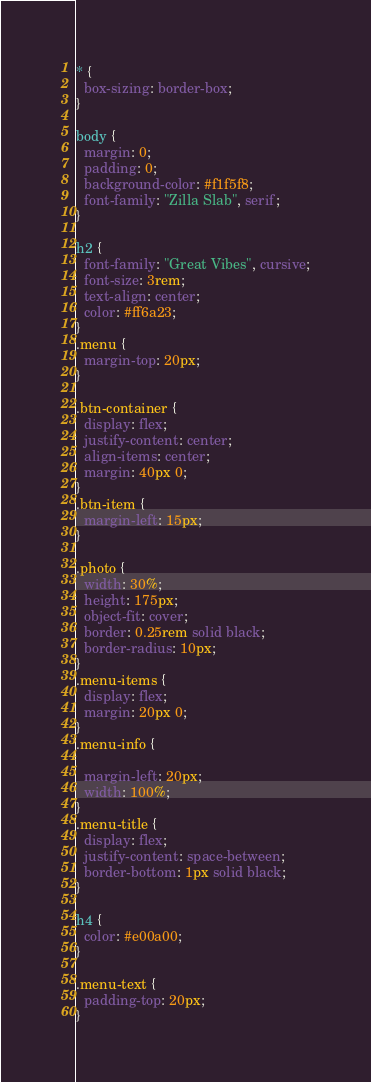<code> <loc_0><loc_0><loc_500><loc_500><_CSS_>* {
  box-sizing: border-box;
}

body {
  margin: 0;
  padding: 0;
  background-color: #f1f5f8;
  font-family: "Zilla Slab", serif;
}

h2 {
  font-family: "Great Vibes", cursive;
  font-size: 3rem;
  text-align: center;
  color: #ff6a23;
}
.menu {
  margin-top: 20px;
}

.btn-container {
  display: flex;
  justify-content: center;
  align-items: center;
  margin: 40px 0;
}
.btn-item {
  margin-left: 15px;
}

.photo {
  width: 30%;
  height: 175px;
  object-fit: cover;
  border: 0.25rem solid black;
  border-radius: 10px;
}
.menu-items {
  display: flex;
  margin: 20px 0;
}
.menu-info {
  
  margin-left: 20px;
  width: 100%;
}
.menu-title {
  display: flex;  
  justify-content: space-between;
  border-bottom: 1px solid black;
}

h4 {
  color: #e00a00;
}

.menu-text {
  padding-top: 20px;
}
</code> 